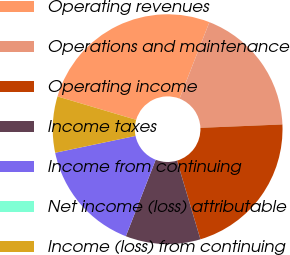<chart> <loc_0><loc_0><loc_500><loc_500><pie_chart><fcel>Operating revenues<fcel>Operations and maintenance<fcel>Operating income<fcel>Income taxes<fcel>Income from continuing<fcel>Net income (loss) attributable<fcel>Income (loss) from continuing<nl><fcel>26.32%<fcel>18.42%<fcel>21.05%<fcel>10.53%<fcel>15.79%<fcel>0.0%<fcel>7.89%<nl></chart> 